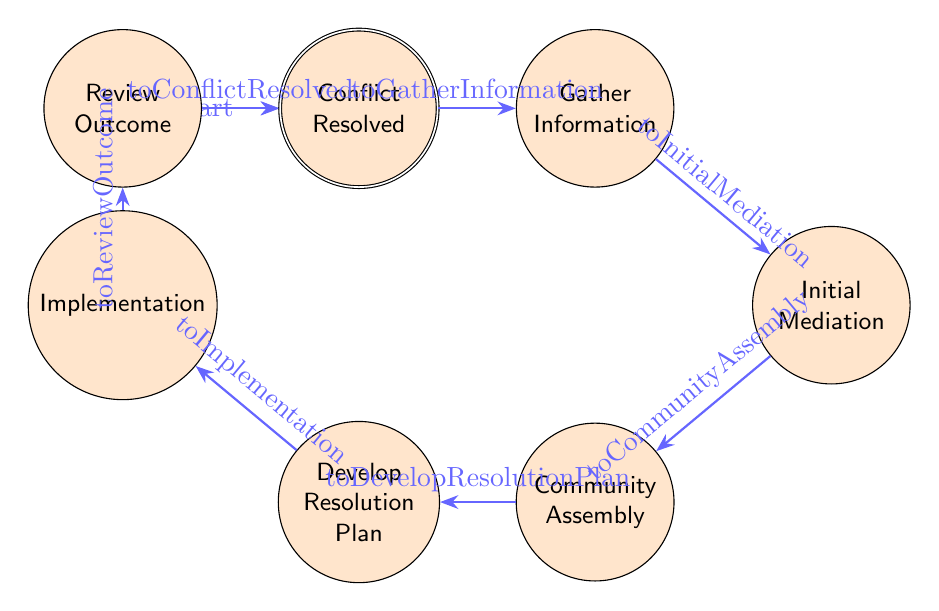What is the starting state of the process? The starting state is labeled "Identify Dispute," indicated by the initial marker.
Answer: Identify Dispute How many states are there in the diagram? There are eight states listed in the diagram, each representing a step in the dispute resolution process.
Answer: 8 What is the last state before the conflict is resolved? The last state before reaching "Conflict Resolved" is "Review Outcome," the state preceding the final accepted state.
Answer: Review Outcome Which state comes after "Community Assembly"? The state that follows "Community Assembly" is "Develop Resolution Plan," according to the transitions shown in the diagram.
Answer: Develop Resolution Plan What is the transition name from "Gather Information" to "Initial Mediation"? The transition from "Gather Information" to "Initial Mediation" is named "toInitialMediation." This is a direct link between those two states.
Answer: toInitialMediation What states are connected by the transition named "toImplementation"? The transition named "toImplementation" connects the states "Develop Resolution Plan" and "Implementation."
Answer: Develop Resolution Plan, Implementation What is the significance of the state "Conflict Resolved"? The state "Conflict Resolved" signifies the formal acknowledgement that the dispute has been successfully resolved, marking the end of the process.
Answer: Formal acknowledgement Which state involves community participation for resolution guidance? The state that involves community participation for resolution guidance is "Community Assembly," where elders and respected members provide input.
Answer: Community Assembly Describe the primary function of the "Initial Mediation" state. The "Initial Mediation" state primarily facilitates preliminary discussions between the disputing parties to understand their perspectives and positions on the issue.
Answer: Facilitate preliminary discussion 